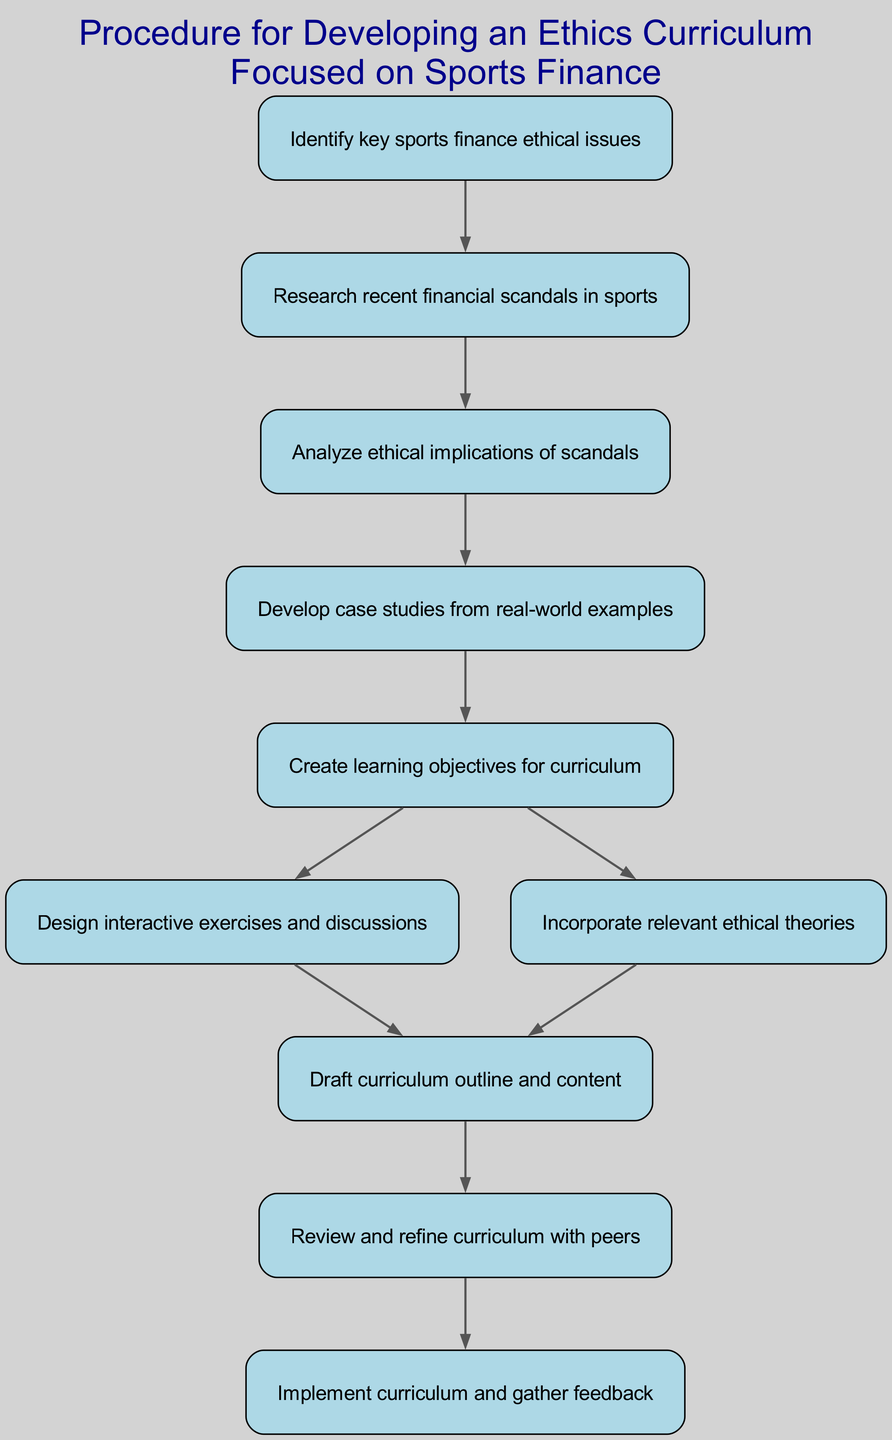What's the first step in the procedure? The first step in the procedure is to identify key sports finance ethical issues. This can be found as the first node in the flow chart.
Answer: Identify key sports finance ethical issues How many nodes are there in the diagram? By counting each distinct step represented in the flow chart, there are a total of ten nodes in the diagram.
Answer: 10 What does step 5 involve? Step 5 involves creating learning objectives for the curriculum, as stated in the respective node of the flow chart.
Answer: Create learning objectives for curriculum What are the outcomes of step 5? Step 5 leads to two outcomes: designing interactive exercises and discussions in step 6 or incorporating relevant ethical theories in step 7, shown by the two edges stemming from node 5.
Answer: Design interactive exercises and discussions and incorporate relevant ethical theories What is the final step in the sequence? The final step in the sequence, as displayed in the flow chart, is to implement the curriculum and gather feedback. This is shown as the last node without any outgoing edges.
Answer: Implement curriculum and gather feedback What precedes the step that involves drafting the curriculum outline and content? The step that involves drafting the curriculum outline and content is preceded by analyzing the ethical implications of scandals as indicated by the direct connection in the flow chart.
Answer: Analyze ethical implications of scandals What is the relationship between step 8 and step 9? Step 8, which is to draft curriculum outline and content, directly leads to step 9, which involves reviewing and refining the curriculum with peers, as highlighted by the directed edge connecting these two nodes.
Answer: Draft curriculum outline and content Which step comes before researching recent financial scandals in sports? The step that comes before researching recent financial scandals in sports is identifying key sports finance ethical issues, as it's the first step in the flow chart.
Answer: Identify key sports finance ethical issues What is the significance of step 6 and step 7 in the curriculum development? Steps 6 and 7 are significant because they focus on designing interactive exercises and discussions or incorporating relevant ethical theories, both of which are essential for creating a well-rounded ethics curriculum in sports finance.
Answer: Design interactive exercises and discussions and incorporate relevant ethical theories 